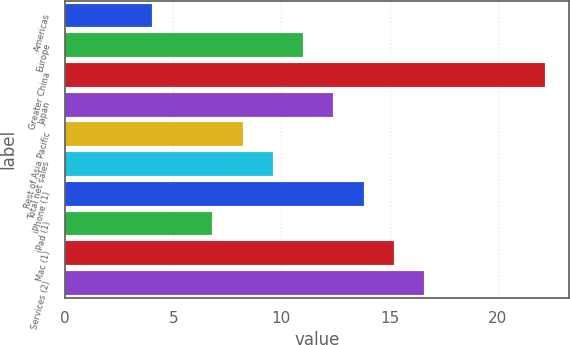<chart> <loc_0><loc_0><loc_500><loc_500><bar_chart><fcel>Americas<fcel>Europe<fcel>Greater China<fcel>Japan<fcel>Rest of Asia Pacific<fcel>Total net sales<fcel>iPhone (1)<fcel>iPad (1)<fcel>Mac (1)<fcel>Services (2)<nl><fcel>4<fcel>11<fcel>22.2<fcel>12.4<fcel>8.2<fcel>9.6<fcel>13.8<fcel>6.8<fcel>15.2<fcel>16.6<nl></chart> 